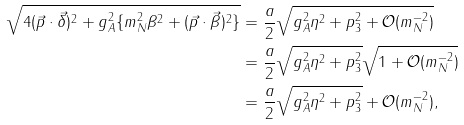Convert formula to latex. <formula><loc_0><loc_0><loc_500><loc_500>\sqrt { 4 ( \vec { p } \cdot \vec { \delta } ) ^ { 2 } + g _ { A } ^ { 2 } \{ m _ { N } ^ { 2 } \beta ^ { 2 } + ( \vec { p } \cdot \vec { \beta } ) ^ { 2 } \} } & = \frac { a } { 2 } \sqrt { g _ { A } ^ { 2 } \eta ^ { 2 } + p _ { 3 } ^ { 2 } + \mathcal { O } ( m _ { N } ^ { - 2 } ) } \\ & = \frac { a } { 2 } \sqrt { g _ { A } ^ { 2 } \eta ^ { 2 } + p _ { 3 } ^ { 2 } } \sqrt { 1 + \mathcal { O } ( m _ { N } ^ { - 2 } ) } \\ & = \frac { a } { 2 } \sqrt { g _ { A } ^ { 2 } \eta ^ { 2 } + p _ { 3 } ^ { 2 } } + \mathcal { O } ( m _ { N } ^ { - 2 } ) ,</formula> 